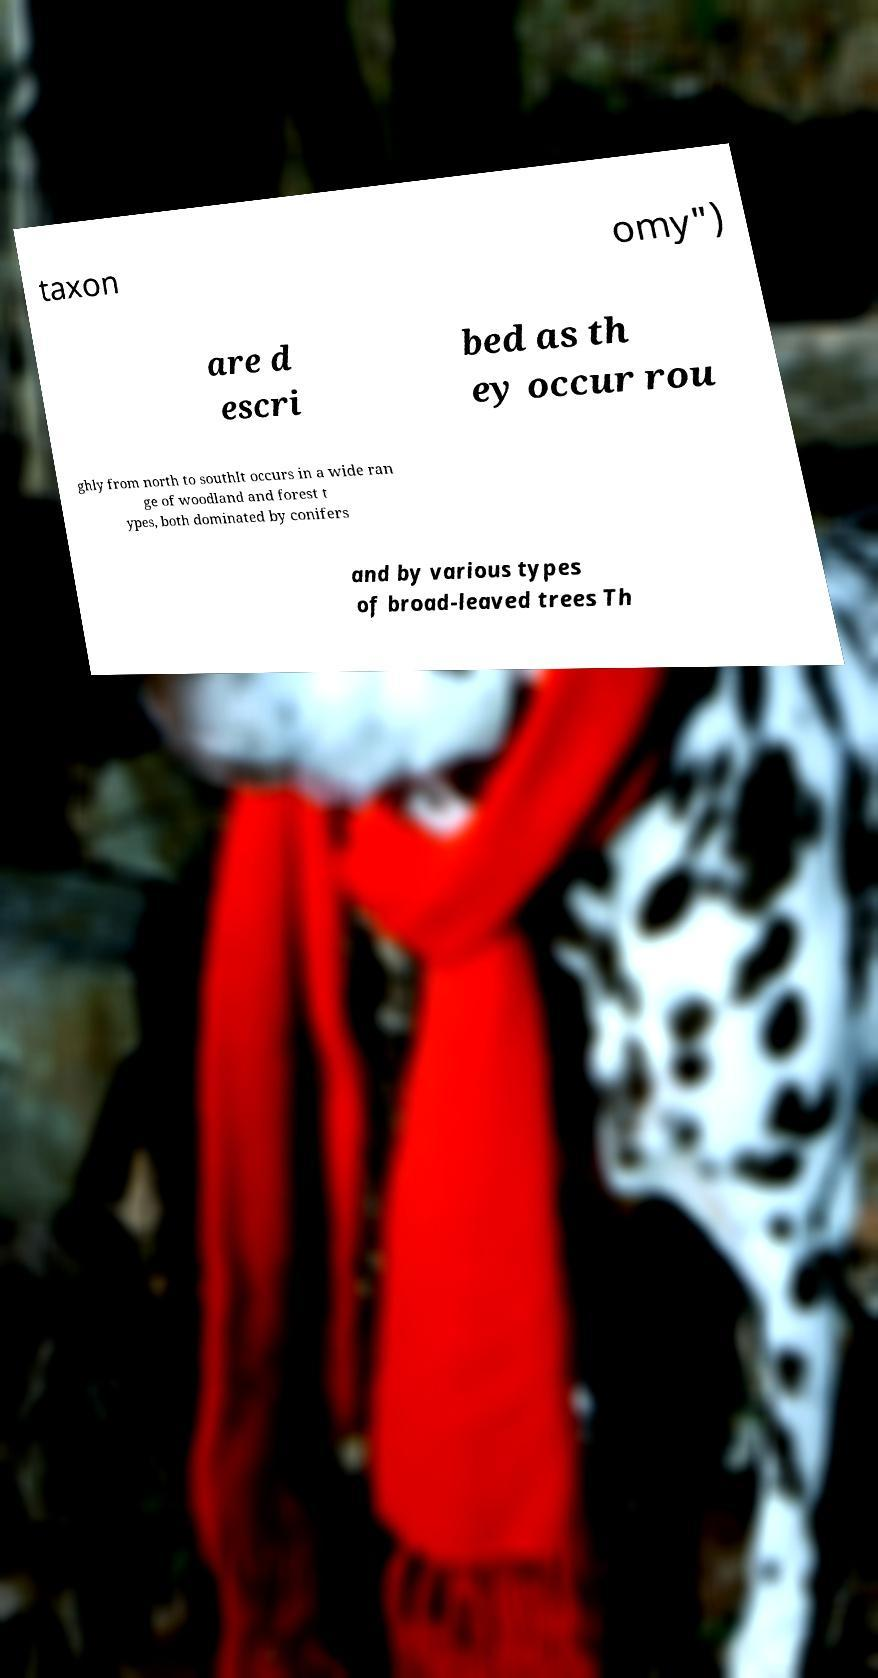Please identify and transcribe the text found in this image. taxon omy") are d escri bed as th ey occur rou ghly from north to southIt occurs in a wide ran ge of woodland and forest t ypes, both dominated by conifers and by various types of broad-leaved trees Th 